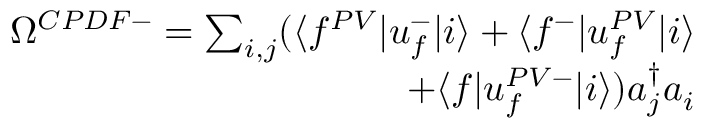<formula> <loc_0><loc_0><loc_500><loc_500>\begin{array} { r } { \Omega ^ { C P D F - } = \sum _ { i , j } ( \langle f ^ { P V } | u _ { f } ^ { - } | i \rangle + \langle f ^ { - } | u _ { f } ^ { P V } | i \rangle } \\ { + \langle f | u _ { f } ^ { P V - } | i \rangle ) a _ { j } ^ { \dagger } a _ { i } } \end{array}</formula> 